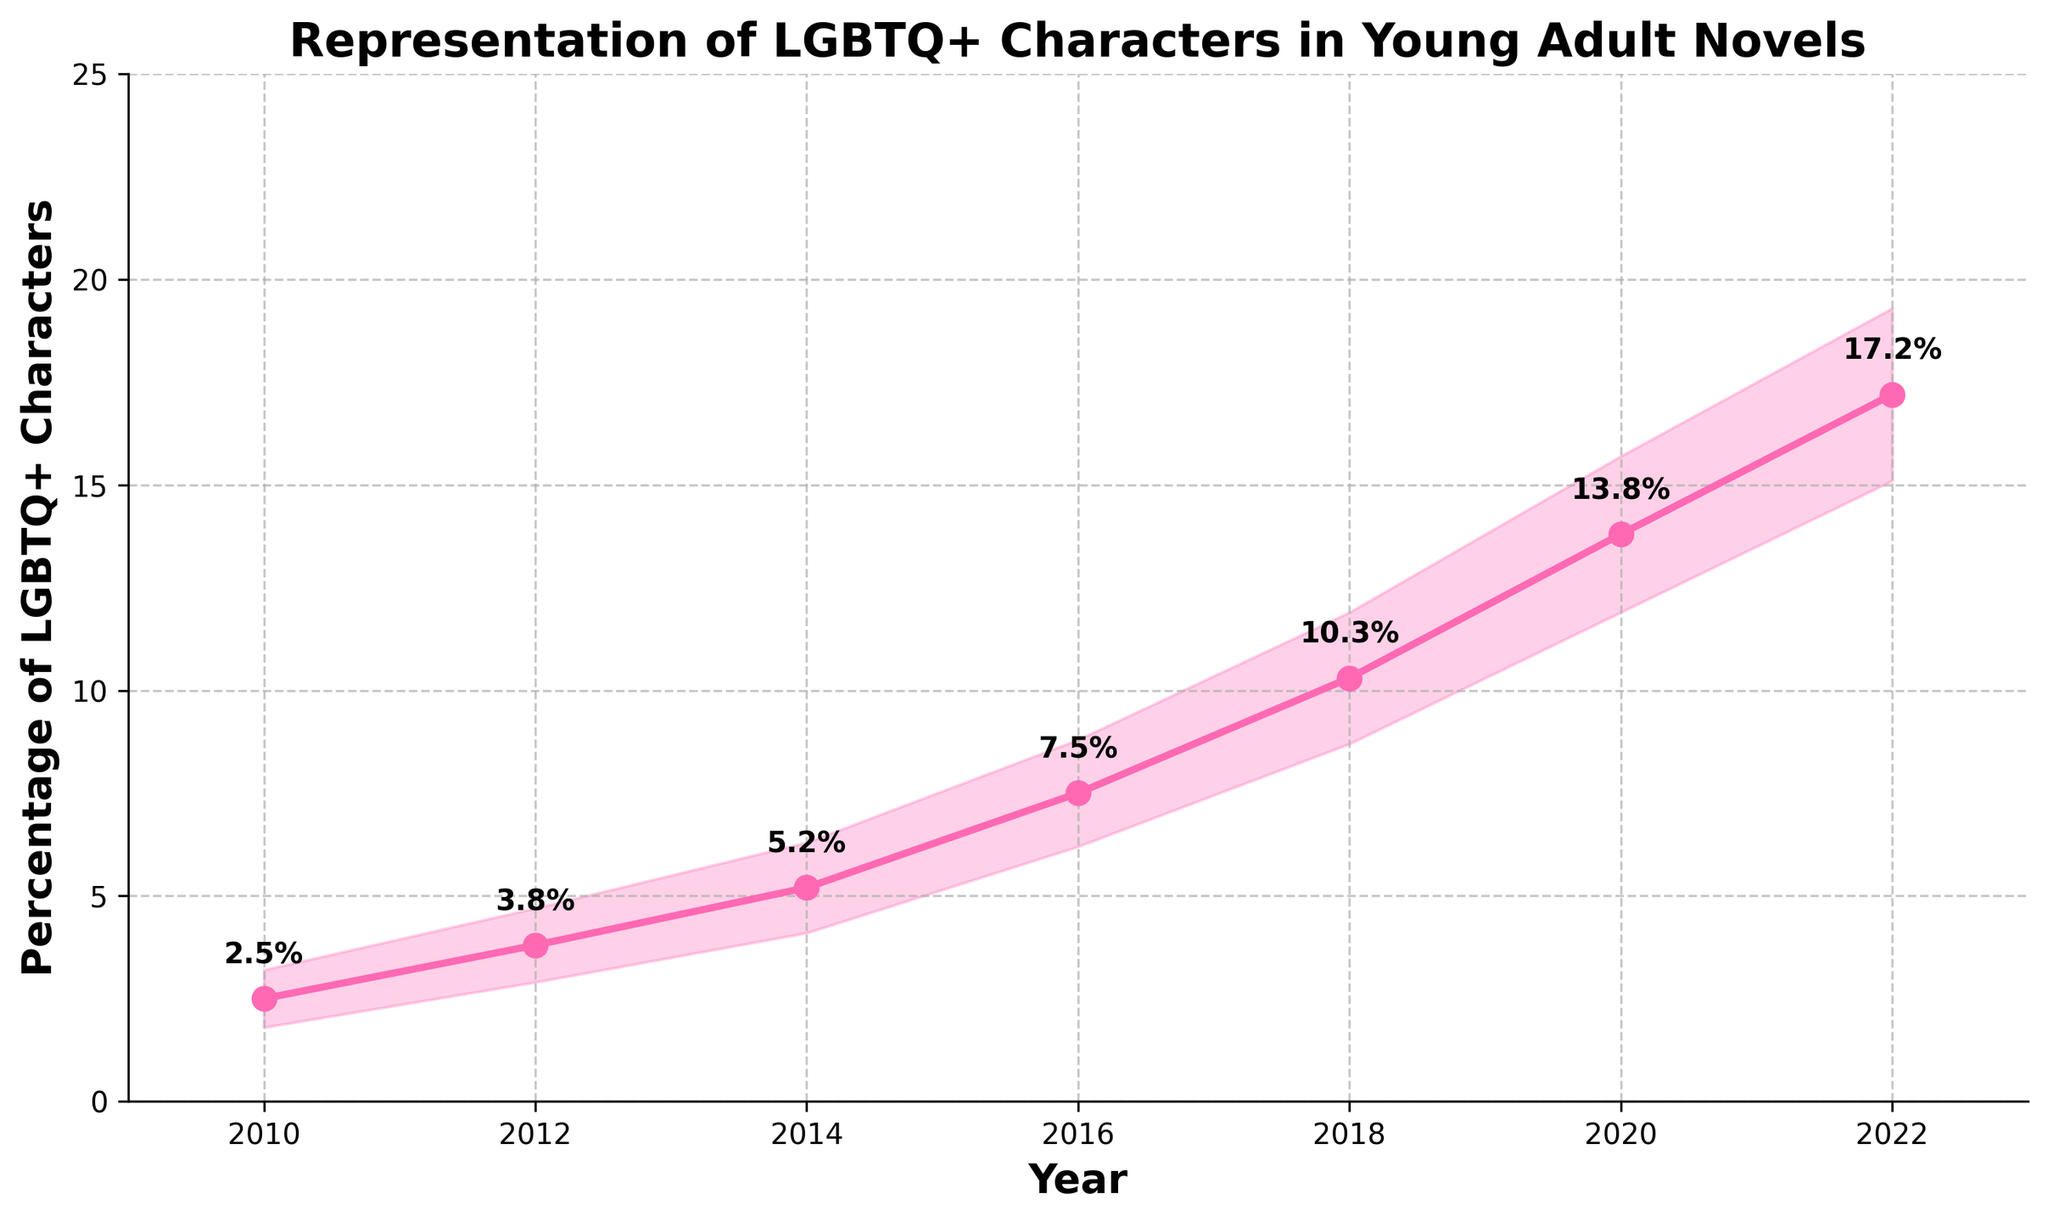What's the title of the figure? The title of the figure is the large text at the top of the plot. It usually describes what the plot is about.
Answer: Representation of LGBTQ+ Characters in Young Adult Novels What is the percentage of LGBTQ+ characters in 2014? Look at the data point on the line corresponding to the year 2014.
Answer: 5.2% By how much did the percentage of LGBTQ+ characters increase from 2010 to 2020? The percentage in 2020 is 13.8% and in 2010 it is 2.5%. Subtracting these values gives the increase. 13.8% - 2.5% = 11.3%
Answer: 11.3% What is the range of estimated percentages of LGBTQ+ characters in 2018 according to the fan chart? The range is given by the lower and upper bounds for the year 2018. The lower bound is 8.7% and the upper bound is 11.9%.
Answer: 8.7% to 11.9% In which year is the highest percentage of LGBTQ+ characters represented? Identify the year with the highest data point on the main line of the plot.
Answer: 2022 Explain the trend in the representation of LGBTQ+ characters from 2010 to 2022. The trend shows a steady increase in the percentage of LGBTQ+ characters from 2.5% in 2010 to 17.2% in 2022, indicating greater representation over time.
Answer: Increasing trend What is the average percentage of LGBTQ+ characters in the years 2010, 2012, and 2014? Add the percentages of these years (2.5% + 3.8% + 5.2%) and then divide by the number of years (3). (2.5 + 3.8 + 5.2)/3 = 3.8333
Answer: 3.83% Which year has the widest range of estimated percentages? Compare the difference between the upper and lower bounds for each year and identify the largest. The difference in 2022 is (19.3 - 15.1) = 4.2, which is the largest.
Answer: 2022 What percentage of LGBTQ+ characters is predicted for 2022 and what confidence interval does the fan suggest? For the year 2022, the main line gives the predicted percentage, and the shaded area gives the confidence interval. The percentage is 17.2%, and the confidence interval is from 15.1% to 19.3%.
Answer: 17.2%, 15.1%-19.3% Are the percentages of LGBTQ+ characters above 10% at any point before 2018? Check the percentages for the years before 2018. The highest percentage before 2018 is in 2016 at 7.5%, which is below 10%.
Answer: No 